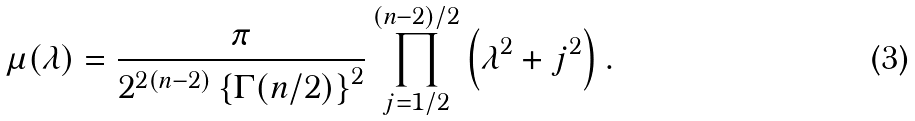<formula> <loc_0><loc_0><loc_500><loc_500>\mu ( \lambda ) = \frac { \pi } { 2 ^ { 2 ( n - 2 ) } \left \{ \Gamma ( n / 2 ) \right \} ^ { 2 } } \prod ^ { ( n - 2 ) / 2 } _ { j = 1 / 2 } \left ( \lambda ^ { 2 } + j ^ { 2 } \right ) .</formula> 